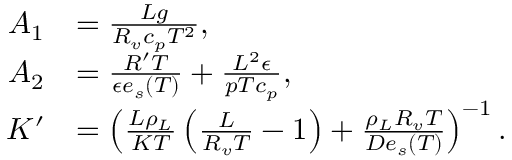Convert formula to latex. <formula><loc_0><loc_0><loc_500><loc_500>\begin{array} { r l } { A _ { 1 } } & { = \frac { L g } { R _ { v } c _ { p } T ^ { 2 } } , } \\ { A _ { 2 } } & { = \frac { R ^ { \prime } T } { \epsilon e _ { s } ( T ) } + \frac { L ^ { 2 } \epsilon } { p T c _ { p } } , } \\ { K ^ { \prime } } & { = \left ( \frac { L \rho _ { L } } { K T } \left ( \frac { L } { R _ { v } T } - 1 \right ) + \frac { \rho _ { L } R _ { v } T } { D e _ { s } ( T ) } \right ) ^ { - 1 } . } \end{array}</formula> 